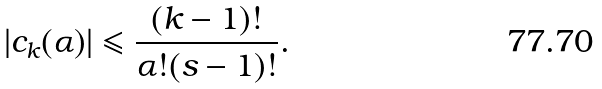Convert formula to latex. <formula><loc_0><loc_0><loc_500><loc_500>| c _ { k } ( \alpha ) | \leqslant \frac { ( k - 1 ) ! } { \alpha ! ( s - 1 ) ! } .</formula> 